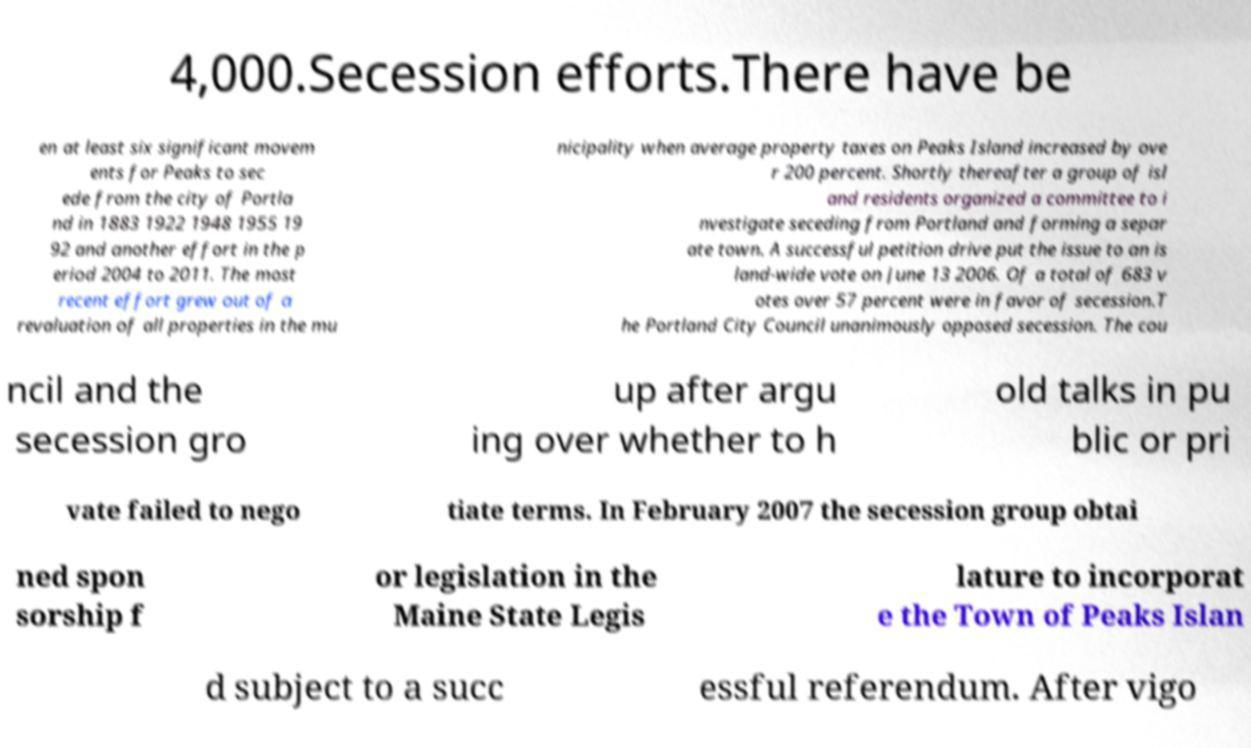Can you accurately transcribe the text from the provided image for me? 4,000.Secession efforts.There have be en at least six significant movem ents for Peaks to sec ede from the city of Portla nd in 1883 1922 1948 1955 19 92 and another effort in the p eriod 2004 to 2011. The most recent effort grew out of a revaluation of all properties in the mu nicipality when average property taxes on Peaks Island increased by ove r 200 percent. Shortly thereafter a group of isl and residents organized a committee to i nvestigate seceding from Portland and forming a separ ate town. A successful petition drive put the issue to an is land-wide vote on June 13 2006. Of a total of 683 v otes over 57 percent were in favor of secession.T he Portland City Council unanimously opposed secession. The cou ncil and the secession gro up after argu ing over whether to h old talks in pu blic or pri vate failed to nego tiate terms. In February 2007 the secession group obtai ned spon sorship f or legislation in the Maine State Legis lature to incorporat e the Town of Peaks Islan d subject to a succ essful referendum. After vigo 